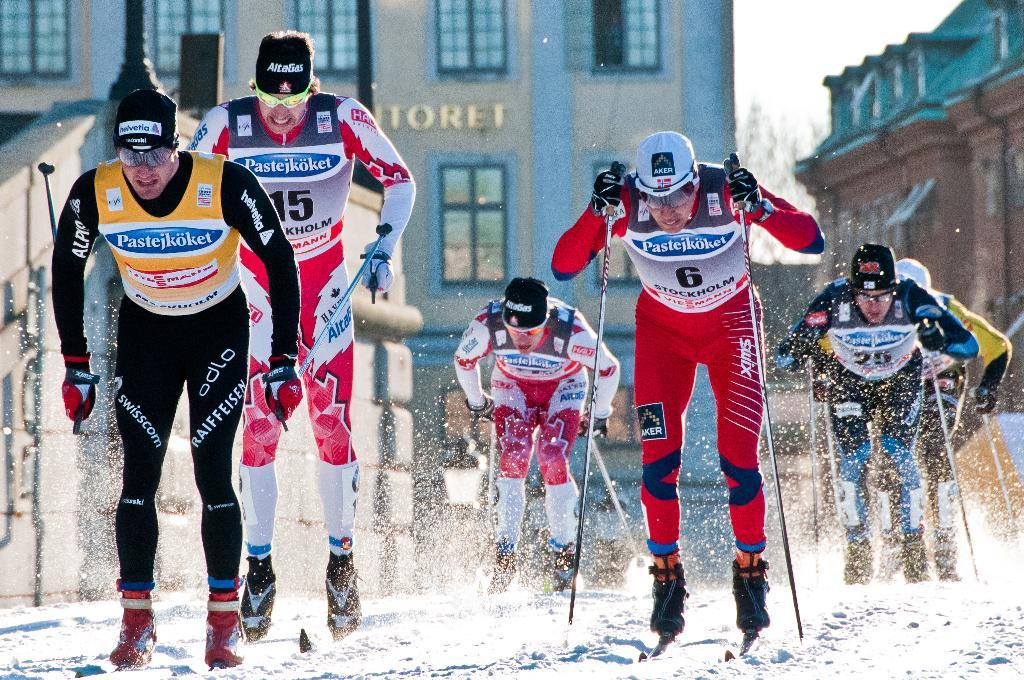What are the persons in the image holding? The persons in the image are holding sticks. What activity are the persons engaged in? The persons are skating on the snow. What can be seen in the background of the image? There are buildings and a tree in the background of the image. What is visible above the persons and the background? The sky is visible in the image. What is the relation between the persons and the title of the image? There is no title mentioned for the image, so it is not possible to determine any relation between the persons and a title. 